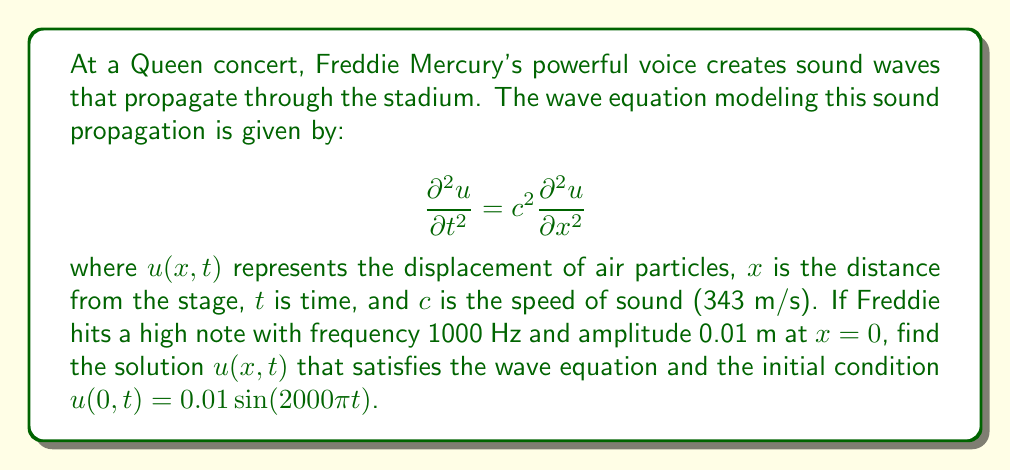Could you help me with this problem? Let's approach this step-by-step:

1) The general solution to the wave equation is of the form:
   $$u(x,t) = f(x-ct) + g(x+ct)$$
   where $f$ and $g$ are arbitrary functions.

2) Given the initial condition at $x=0$, we can write:
   $$u(0,t) = f(-ct) + g(ct) = 0.01 \sin(2000\pi t)$$

3) To satisfy this condition, we can choose:
   $$f(-ct) = 0.005 \sin(2000\pi t)$$
   $$g(ct) = 0.005 \sin(2000\pi t)$$

4) Now, we need to express these in terms of $(x-ct)$ and $(x+ct)$:
   $$f(x-ct) = 0.005 \sin(2000\pi (\frac{x-ct}{-c})) = 0.005 \sin(2000\pi (\frac{ct-x}{c}))$$
   $$g(x+ct) = 0.005 \sin(2000\pi (\frac{x+ct}{c}))$$

5) The complete solution is the sum of these two functions:
   $$u(x,t) = 0.005 \sin(2000\pi (\frac{ct-x}{c})) + 0.005 \sin(2000\pi (\frac{x+ct}{c}))$$

6) Simplify using the trigonometric identity for the sum of sines:
   $$\sin A + \sin B = 2 \sin(\frac{A+B}{2}) \cos(\frac{A-B}{2})$$

7) In our case:
   $$A = 2000\pi (\frac{ct-x}{c}), B = 2000\pi (\frac{x+ct}{c})$$
   $$\frac{A+B}{2} = 2000\pi t, \frac{A-B}{2} = -\frac{2000\pi x}{c}$$

8) Applying the identity and simplifying:
   $$u(x,t) = 0.01 \sin(2000\pi t) \cos(\frac{2000\pi x}{c})$$

9) Substitute $c = 343$ m/s:
   $$u(x,t) = 0.01 \sin(2000\pi t) \cos(\frac{2000\pi x}{343})$$
Answer: $$u(x,t) = 0.01 \sin(2000\pi t) \cos(\frac{2000\pi x}{343})$$ 